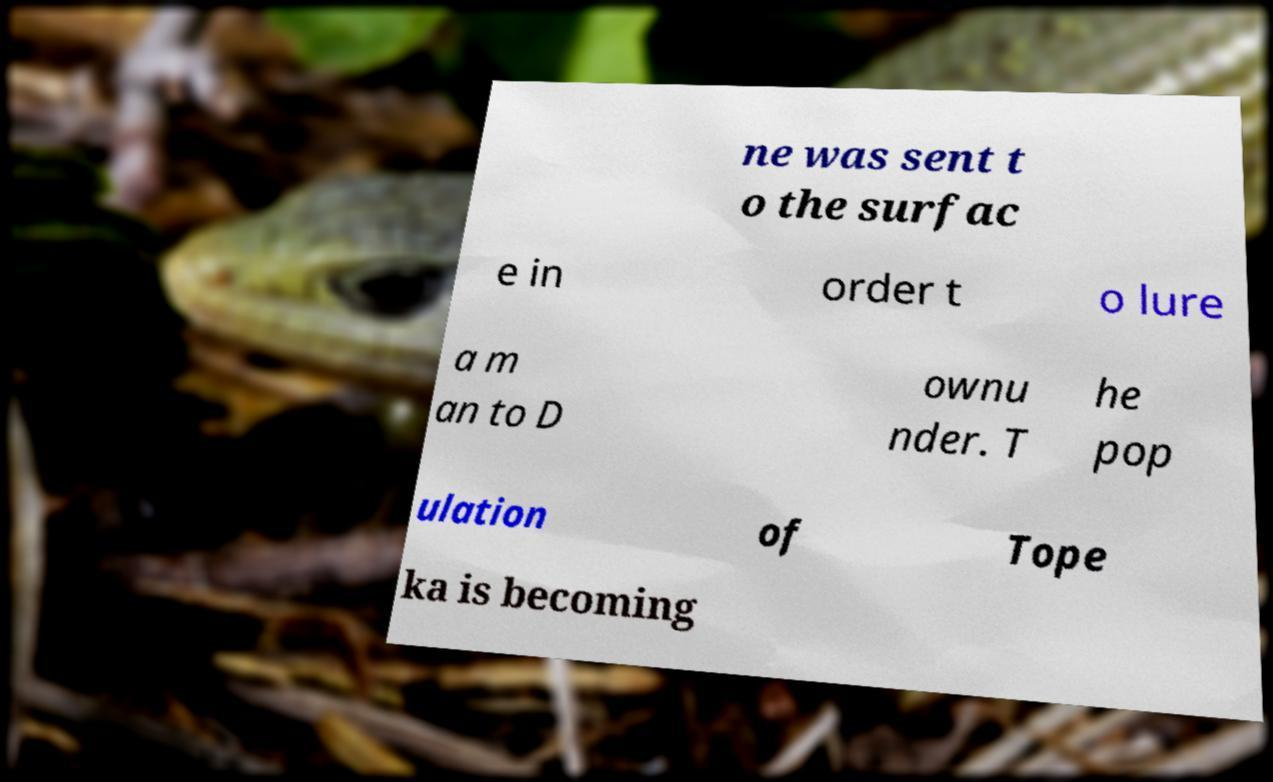Could you extract and type out the text from this image? ne was sent t o the surfac e in order t o lure a m an to D ownu nder. T he pop ulation of Tope ka is becoming 